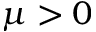Convert formula to latex. <formula><loc_0><loc_0><loc_500><loc_500>\mu > 0</formula> 